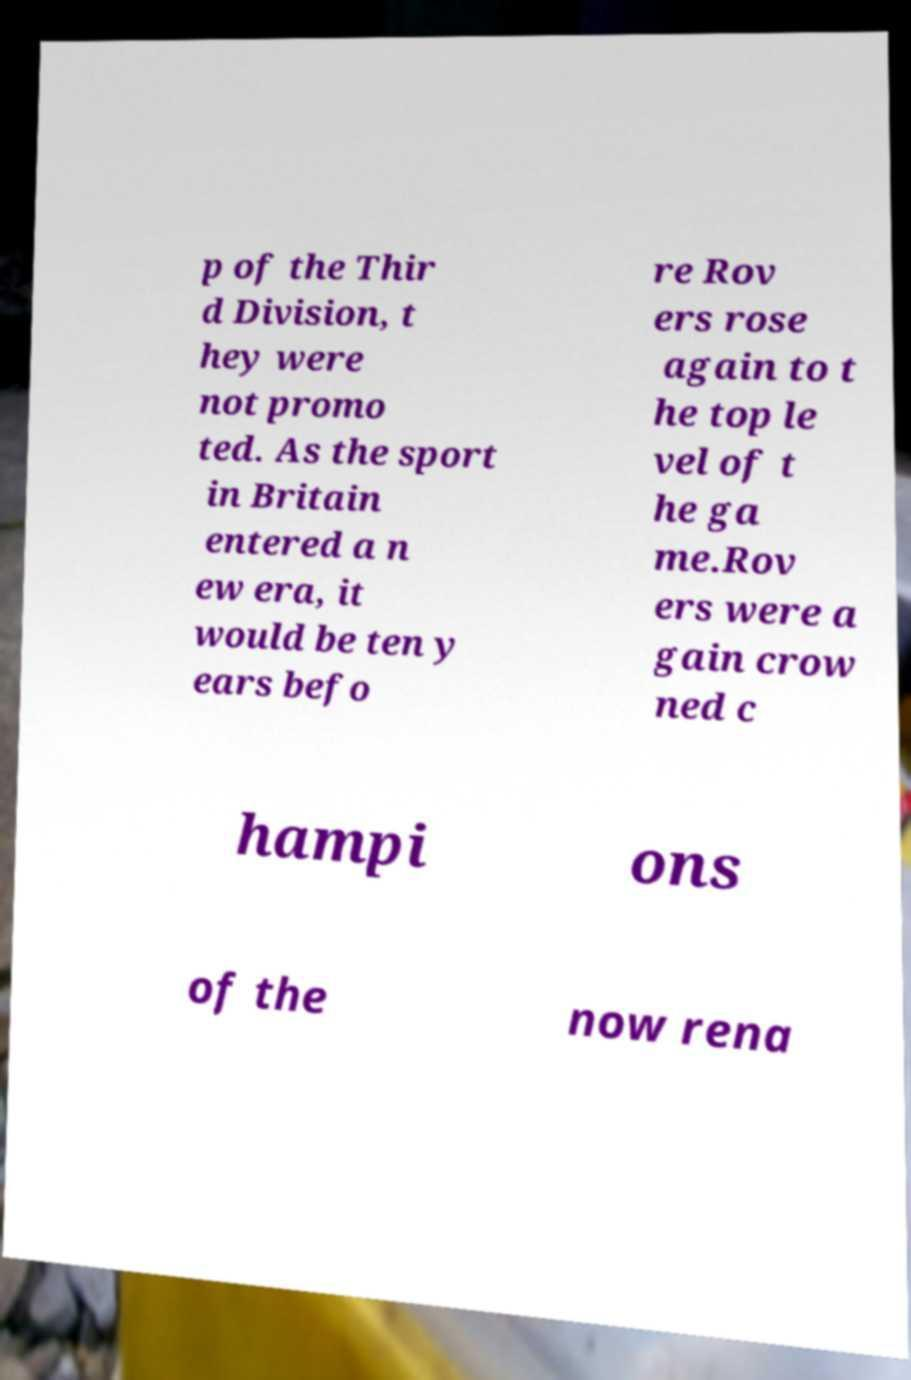Please identify and transcribe the text found in this image. p of the Thir d Division, t hey were not promo ted. As the sport in Britain entered a n ew era, it would be ten y ears befo re Rov ers rose again to t he top le vel of t he ga me.Rov ers were a gain crow ned c hampi ons of the now rena 